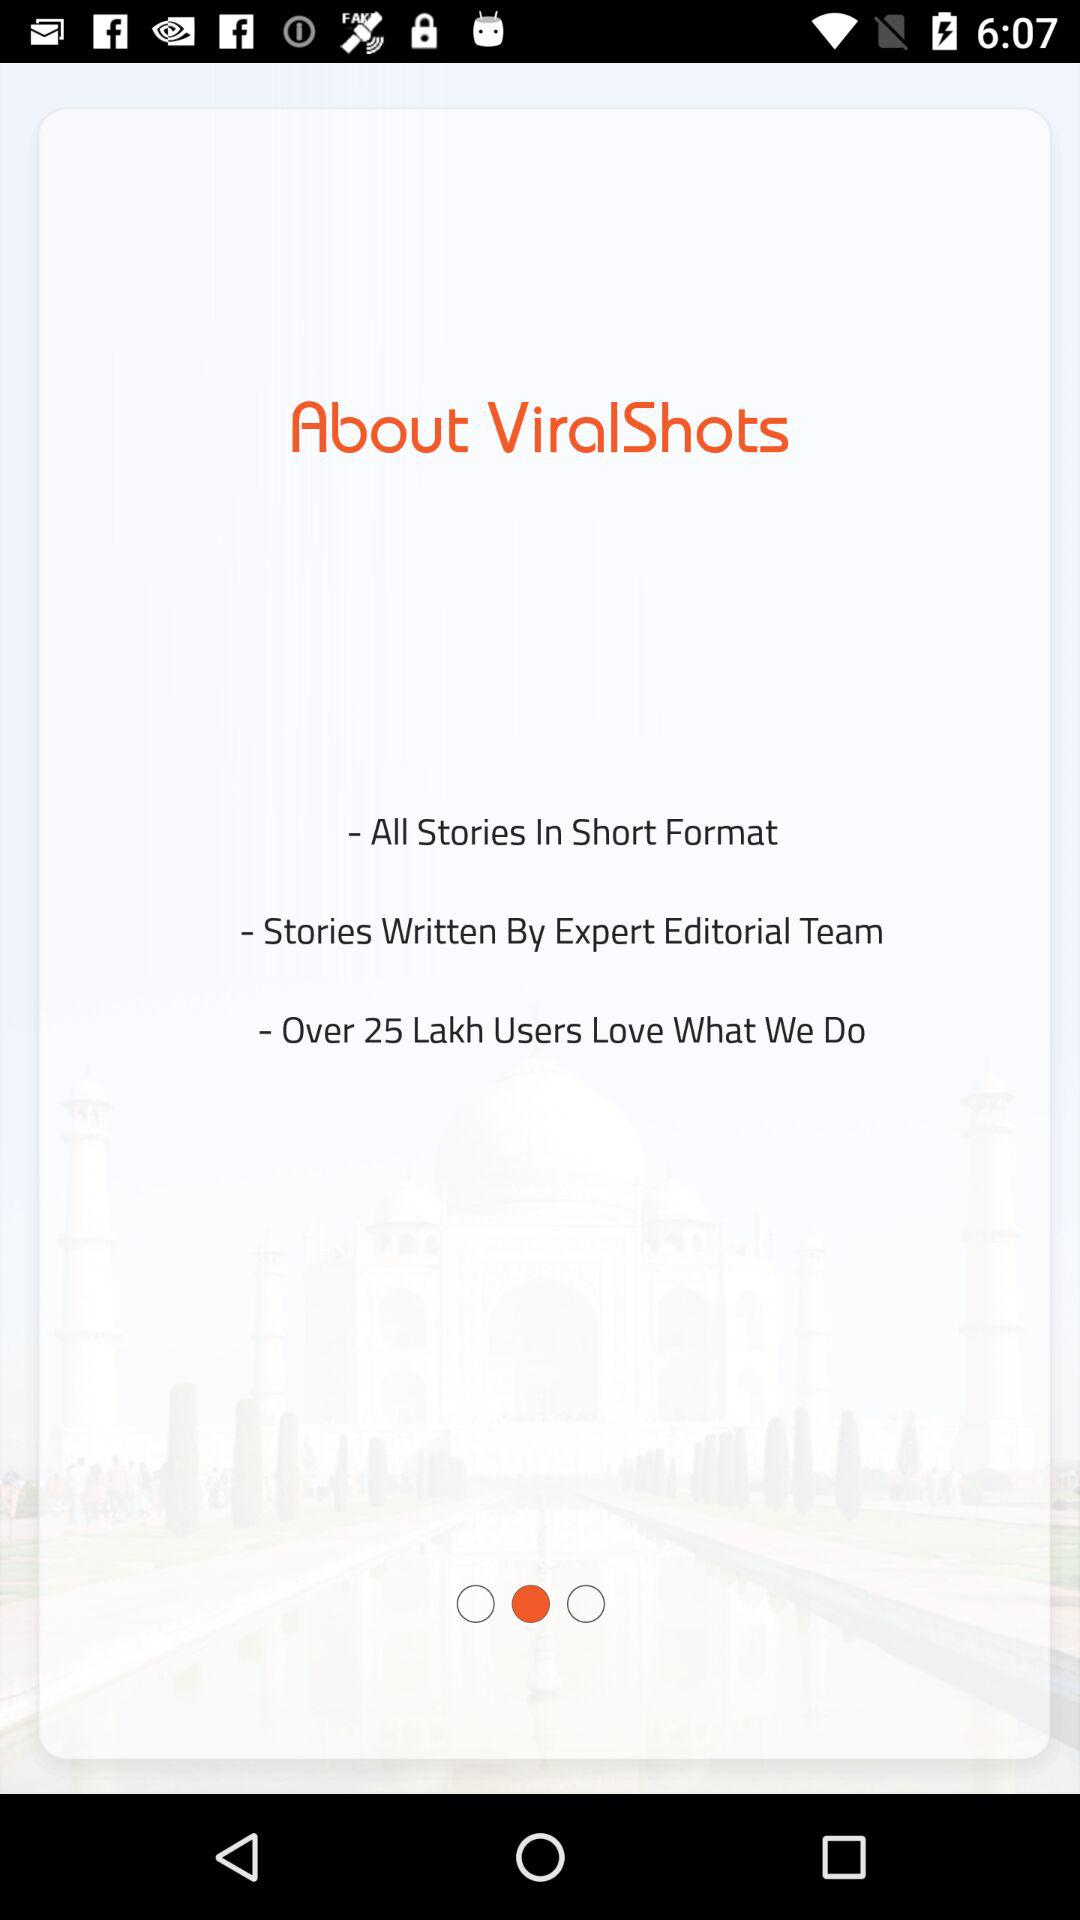What is the application name? The application name is "ViralShots". 